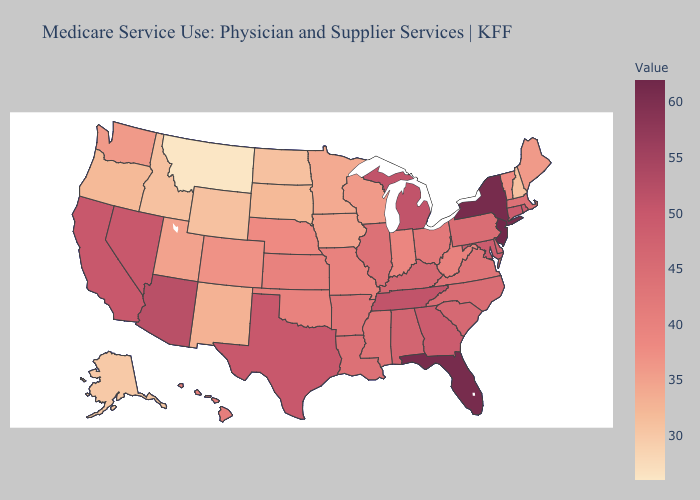Does the map have missing data?
Keep it brief. No. Does New Jersey have the highest value in the USA?
Quick response, please. Yes. Does New Hampshire have the lowest value in the Northeast?
Quick response, please. Yes. Which states have the lowest value in the Northeast?
Quick response, please. New Hampshire. Which states have the lowest value in the West?
Short answer required. Montana. 